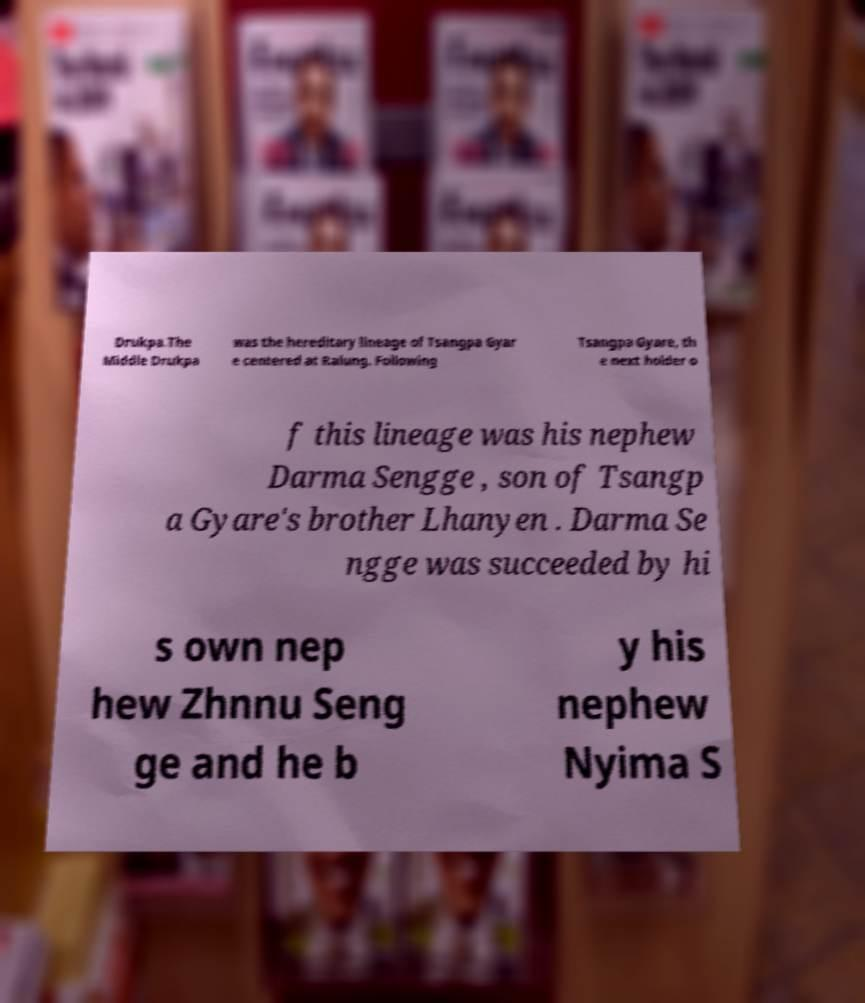Please identify and transcribe the text found in this image. Drukpa.The Middle Drukpa was the hereditary lineage of Tsangpa Gyar e centered at Ralung. Following Tsangpa Gyare, th e next holder o f this lineage was his nephew Darma Sengge , son of Tsangp a Gyare's brother Lhanyen . Darma Se ngge was succeeded by hi s own nep hew Zhnnu Seng ge and he b y his nephew Nyima S 